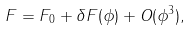Convert formula to latex. <formula><loc_0><loc_0><loc_500><loc_500>F = F _ { 0 } + \delta F ( \phi ) + O ( \phi ^ { 3 } ) ,</formula> 